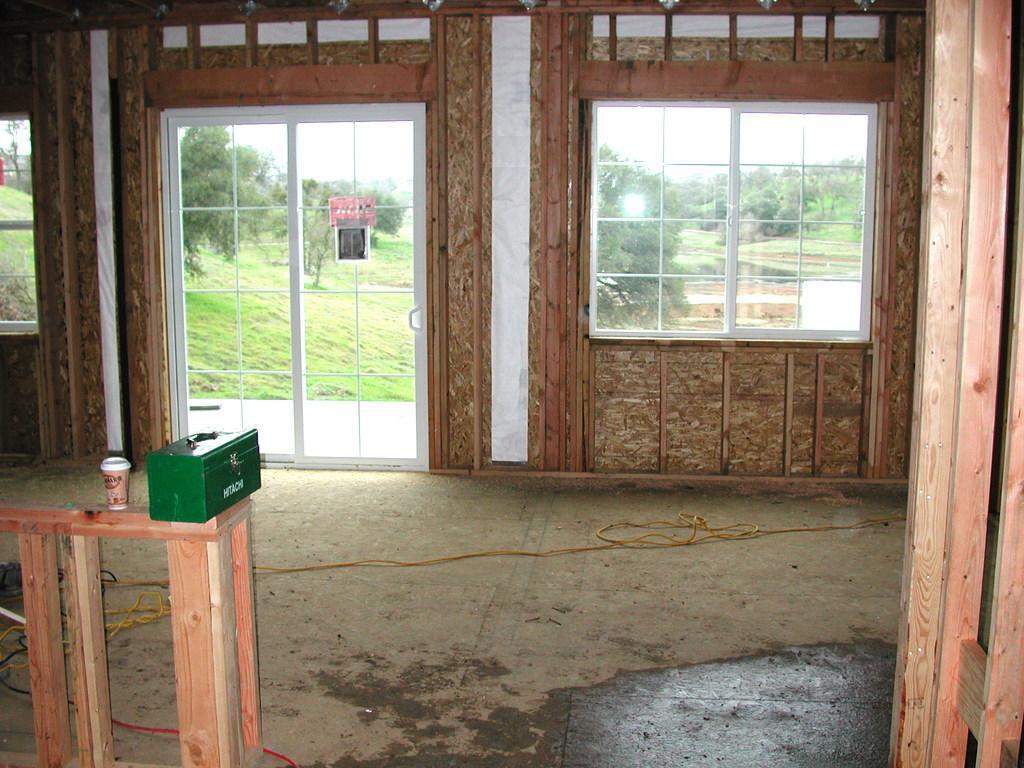How would you summarize this image in a sentence or two? This is an inner view of a house containing some windows, wires on the floor, a wooden pole and a table containing a glass and a box on it. On the backside we can see a group of trees, grass and the sky. 